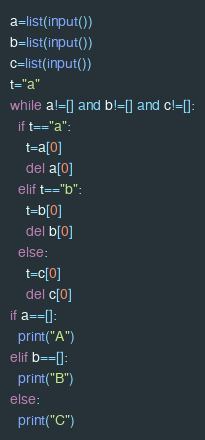<code> <loc_0><loc_0><loc_500><loc_500><_Python_>a=list(input())
b=list(input())
c=list(input())
t="a"
while a!=[] and b!=[] and c!=[]:
  if t=="a":
    t=a[0]
    del a[0]
  elif t=="b":
    t=b[0]
    del b[0]
  else:
    t=c[0]
    del c[0]
if a==[]:
  print("A")
elif b==[]:
  print("B")
else:
  print("C")</code> 